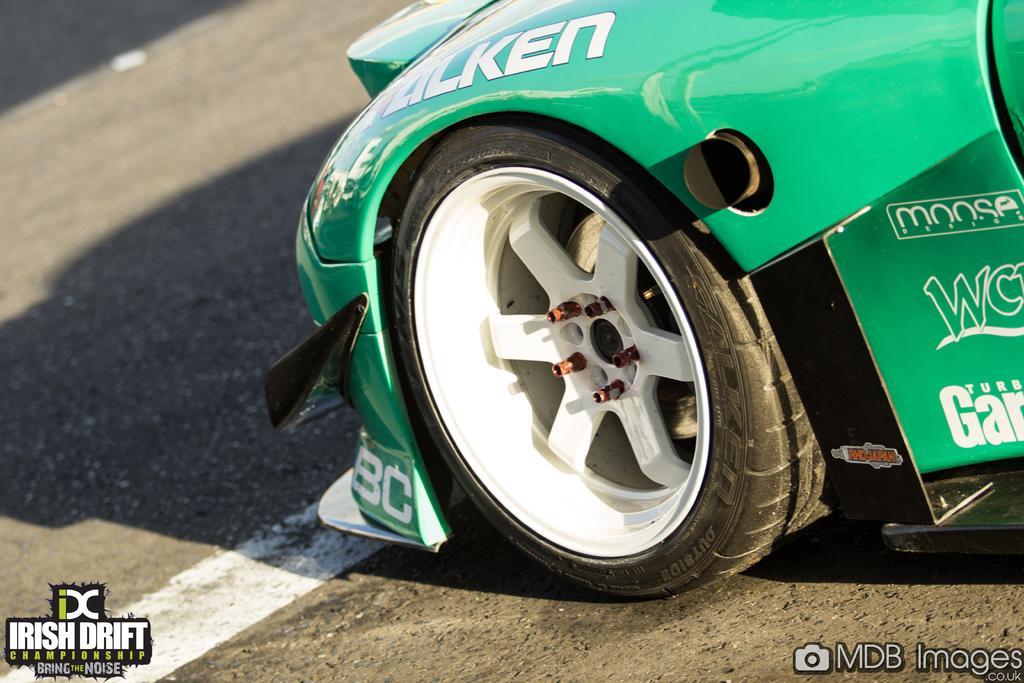Can you describe this image briefly? There is green color car on the road. 